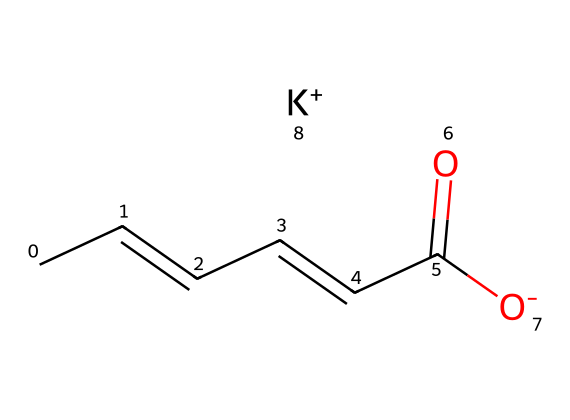What is the molecular formula of potassium sorbate? The molecular formula can be determined from the SMILES representation by counting the carbon (C), hydrogen (H), oxygen (O), and potassium (K) atoms. Here, there are 6 carbons, 7 hydrogens, 2 oxygens, and 1 potassium. Therefore, the molecular formula is C6H7O2K.
Answer: C6H7O2K How many carbon atoms are present in this chemical? By analyzing the SMILES representation, I count six carbon atoms (C) in the structure indicated by "CC=CC=CC".
Answer: 6 What type of bond connects the carbon atoms in this structure? The presence of "=" in the SMILES representation indicates that there are double bonds between some of the carbon atoms. Therefore, some bonds are double bonds.
Answer: double bonds What role does potassium play in this compound? Potassium (K) acts as a counterion to the negatively charged carboxylate group (-COO-) in potassium sorbate, stabilizing the overall structure in solution.
Answer: stabilizing Is potassium sorbate considered a preservative? Yes, potassium sorbate is commonly used as a preservative in food and personal care products to inhibit the growth of mold, yeast, and fungi.
Answer: yes How does the presence of a carboxylate group affect the solubility of potassium sorbate? The carboxylate group (-COO-) enhances the solubility of potassium sorbate in water, as it can interact with water through hydrogen bonding.
Answer: enhances solubility What is the significance of having an unsaturated bond in potassium sorbate? The unsaturated bond (double bond) in potassium sorbate contributes to its ability to react with other chemicals, influencing its function as a preservative.
Answer: reactive function 